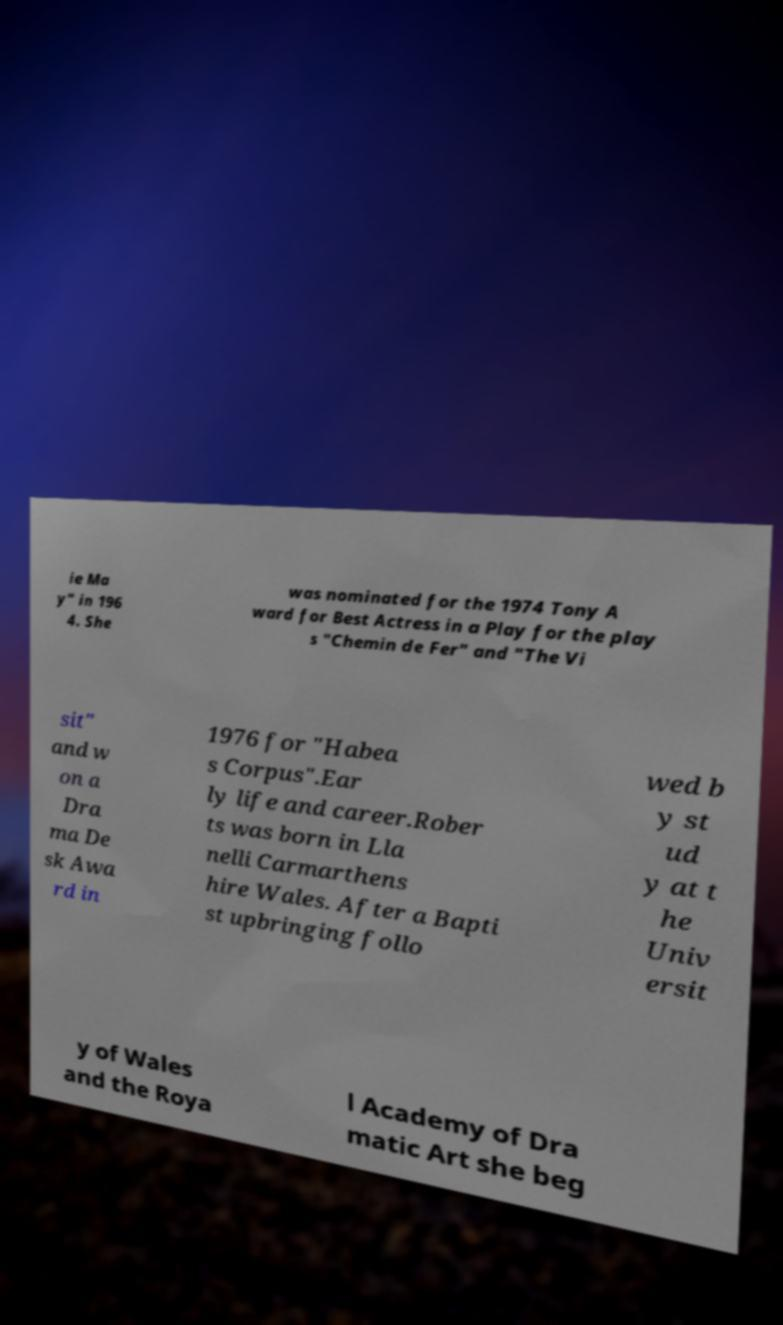Can you read and provide the text displayed in the image?This photo seems to have some interesting text. Can you extract and type it out for me? ie Ma y" in 196 4. She was nominated for the 1974 Tony A ward for Best Actress in a Play for the play s "Chemin de Fer" and "The Vi sit" and w on a Dra ma De sk Awa rd in 1976 for "Habea s Corpus".Ear ly life and career.Rober ts was born in Lla nelli Carmarthens hire Wales. After a Bapti st upbringing follo wed b y st ud y at t he Univ ersit y of Wales and the Roya l Academy of Dra matic Art she beg 